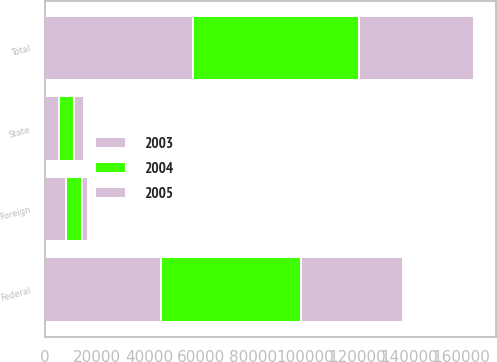Convert chart to OTSL. <chart><loc_0><loc_0><loc_500><loc_500><stacked_bar_chart><ecel><fcel>Federal<fcel>State<fcel>Foreign<fcel>Total<nl><fcel>2003<fcel>44736<fcel>5253<fcel>8060<fcel>56862<nl><fcel>2004<fcel>53810<fcel>5874<fcel>6023<fcel>63905<nl><fcel>2005<fcel>38954<fcel>3723<fcel>2561<fcel>44296<nl></chart> 